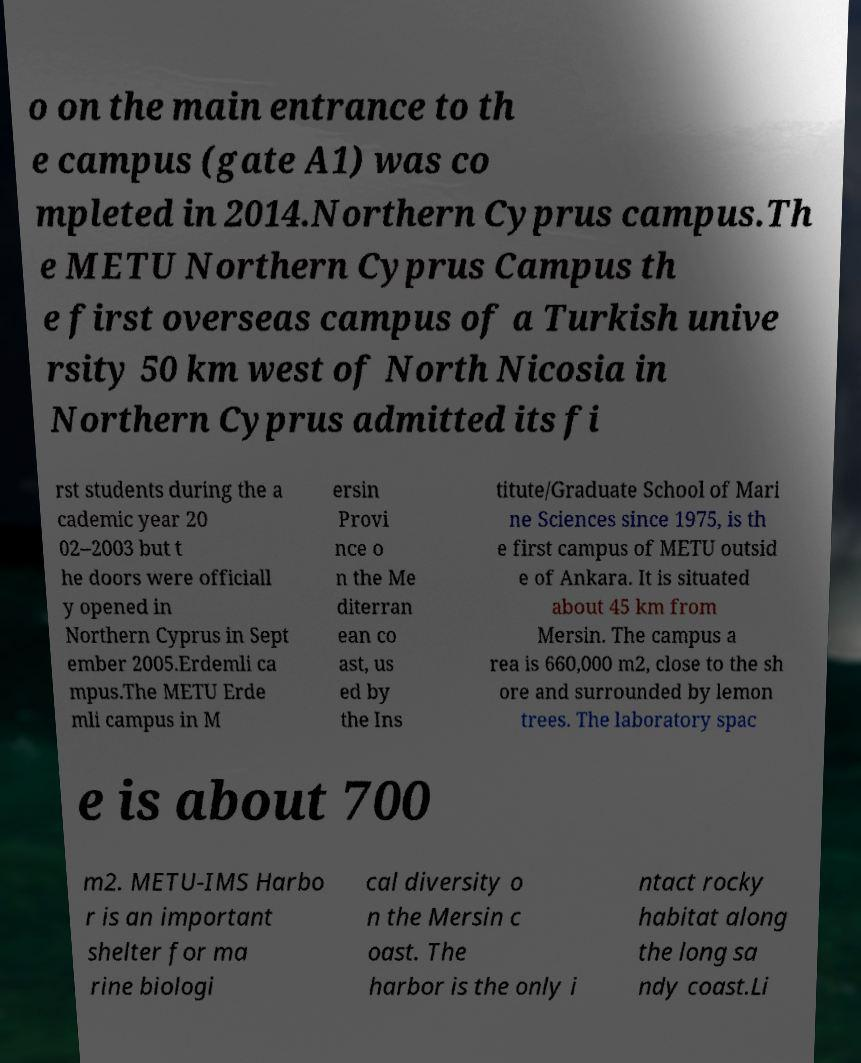Can you read and provide the text displayed in the image?This photo seems to have some interesting text. Can you extract and type it out for me? o on the main entrance to th e campus (gate A1) was co mpleted in 2014.Northern Cyprus campus.Th e METU Northern Cyprus Campus th e first overseas campus of a Turkish unive rsity 50 km west of North Nicosia in Northern Cyprus admitted its fi rst students during the a cademic year 20 02–2003 but t he doors were officiall y opened in Northern Cyprus in Sept ember 2005.Erdemli ca mpus.The METU Erde mli campus in M ersin Provi nce o n the Me diterran ean co ast, us ed by the Ins titute/Graduate School of Mari ne Sciences since 1975, is th e first campus of METU outsid e of Ankara. It is situated about 45 km from Mersin. The campus a rea is 660,000 m2, close to the sh ore and surrounded by lemon trees. The laboratory spac e is about 700 m2. METU-IMS Harbo r is an important shelter for ma rine biologi cal diversity o n the Mersin c oast. The harbor is the only i ntact rocky habitat along the long sa ndy coast.Li 